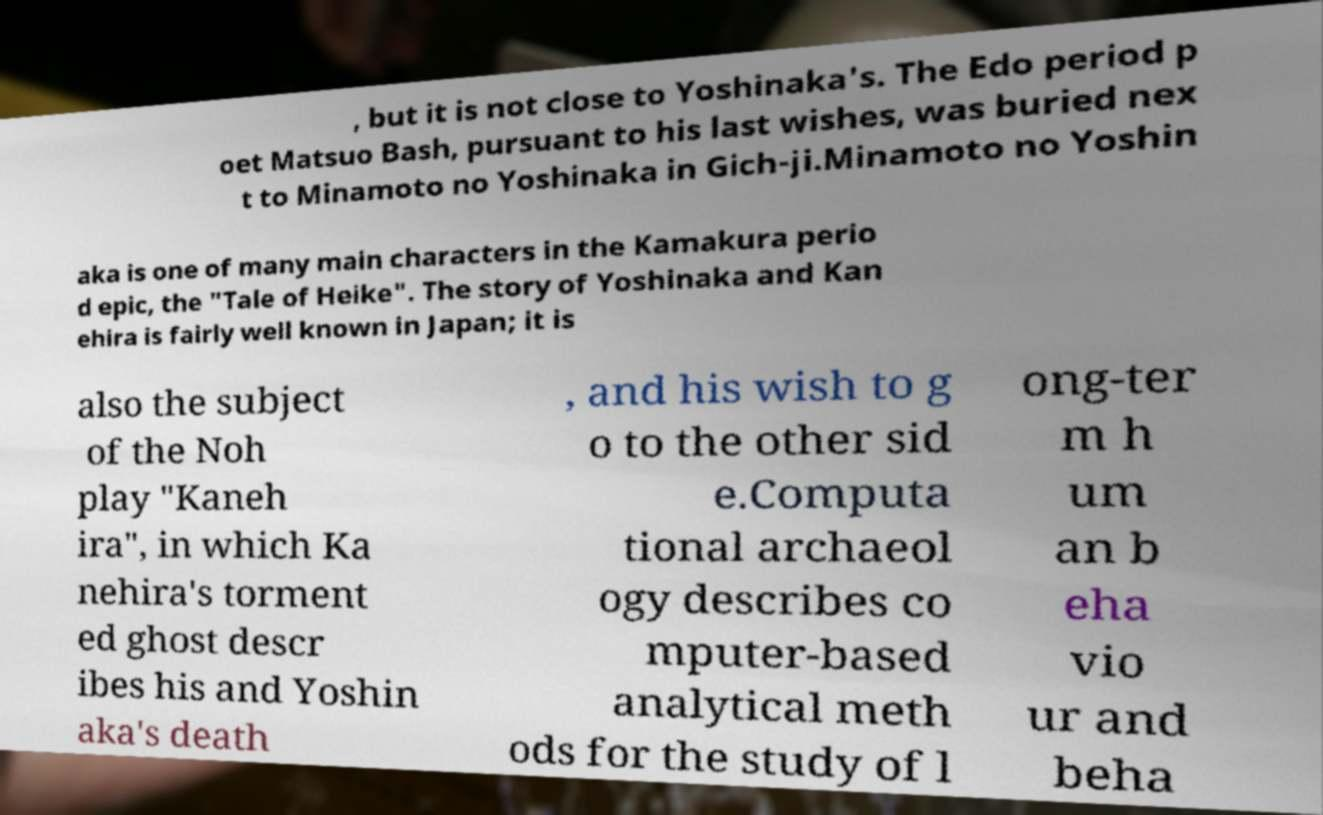Please read and relay the text visible in this image. What does it say? , but it is not close to Yoshinaka's. The Edo period p oet Matsuo Bash, pursuant to his last wishes, was buried nex t to Minamoto no Yoshinaka in Gich-ji.Minamoto no Yoshin aka is one of many main characters in the Kamakura perio d epic, the "Tale of Heike". The story of Yoshinaka and Kan ehira is fairly well known in Japan; it is also the subject of the Noh play "Kaneh ira", in which Ka nehira's torment ed ghost descr ibes his and Yoshin aka's death , and his wish to g o to the other sid e.Computa tional archaeol ogy describes co mputer-based analytical meth ods for the study of l ong-ter m h um an b eha vio ur and beha 